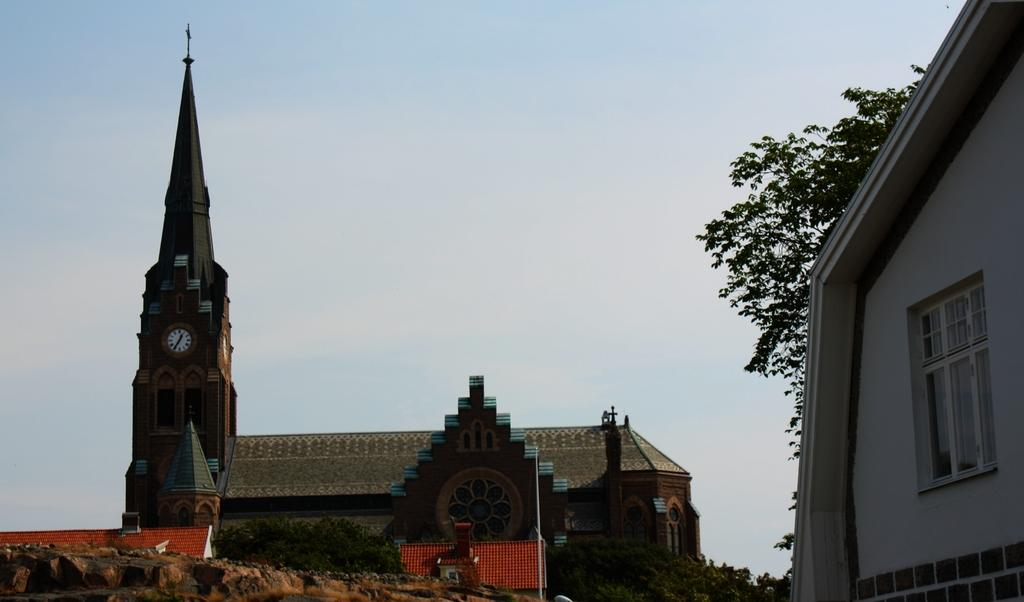What type of structures can be seen in the image? There are buildings in the image, including a clock tower. Can you describe the background of the image? There is a tree and the sky visible in the background of the image. What type of news is being reported by the shoes in the image? There are no shoes present in the image, and therefore no news can be reported by them. 